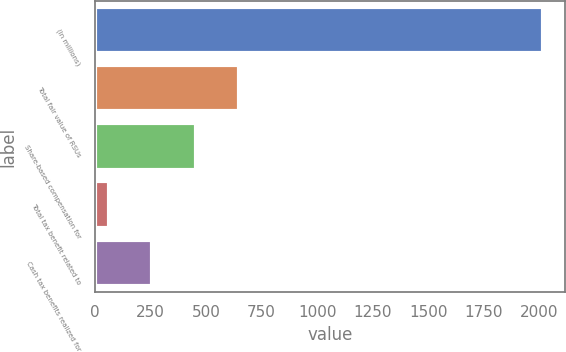<chart> <loc_0><loc_0><loc_500><loc_500><bar_chart><fcel>(In millions)<fcel>Total fair value of RSUs<fcel>Share-based compensation for<fcel>Total tax benefit related to<fcel>Cash tax benefits realized for<nl><fcel>2015<fcel>648.6<fcel>453.4<fcel>63<fcel>258.2<nl></chart> 